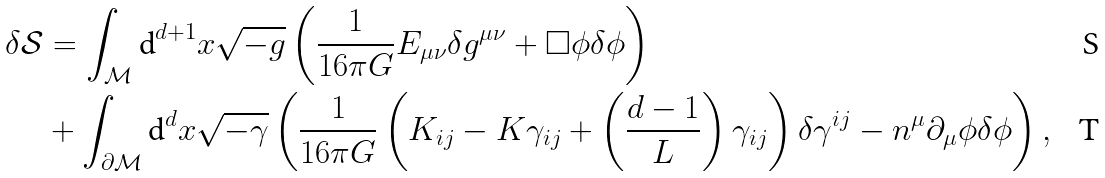<formula> <loc_0><loc_0><loc_500><loc_500>\delta \mathcal { S } & = \int _ { \mathcal { M } } \text {d} ^ { d + 1 } x \sqrt { - g } \left ( \frac { 1 } { 1 6 \pi G } E _ { \mu \nu } \delta g ^ { \mu \nu } + \Box \phi \delta \phi \right ) \\ & + \int _ { \partial \mathcal { M } } \text {d} ^ { d } x \sqrt { - \gamma } \left ( \frac { 1 } { 1 6 \pi G } \left ( K _ { i j } - K \gamma _ { i j } + \left ( \frac { d - 1 } { L } \right ) \gamma _ { i j } \right ) \delta \gamma ^ { i j } - n ^ { \mu } \partial _ { \mu } \phi \delta \phi \right ) ,</formula> 